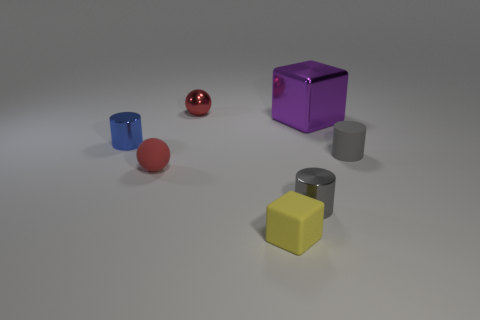Subtract all tiny blue metallic cylinders. How many cylinders are left? 2 Subtract all cylinders. How many objects are left? 4 Add 6 large purple shiny balls. How many large purple shiny balls exist? 6 Add 2 big blue shiny cylinders. How many objects exist? 9 Subtract all blue cylinders. How many cylinders are left? 2 Subtract 2 red balls. How many objects are left? 5 Subtract 1 cylinders. How many cylinders are left? 2 Subtract all red cylinders. Subtract all green spheres. How many cylinders are left? 3 Subtract all red cylinders. How many yellow cubes are left? 1 Subtract all small red objects. Subtract all small yellow objects. How many objects are left? 4 